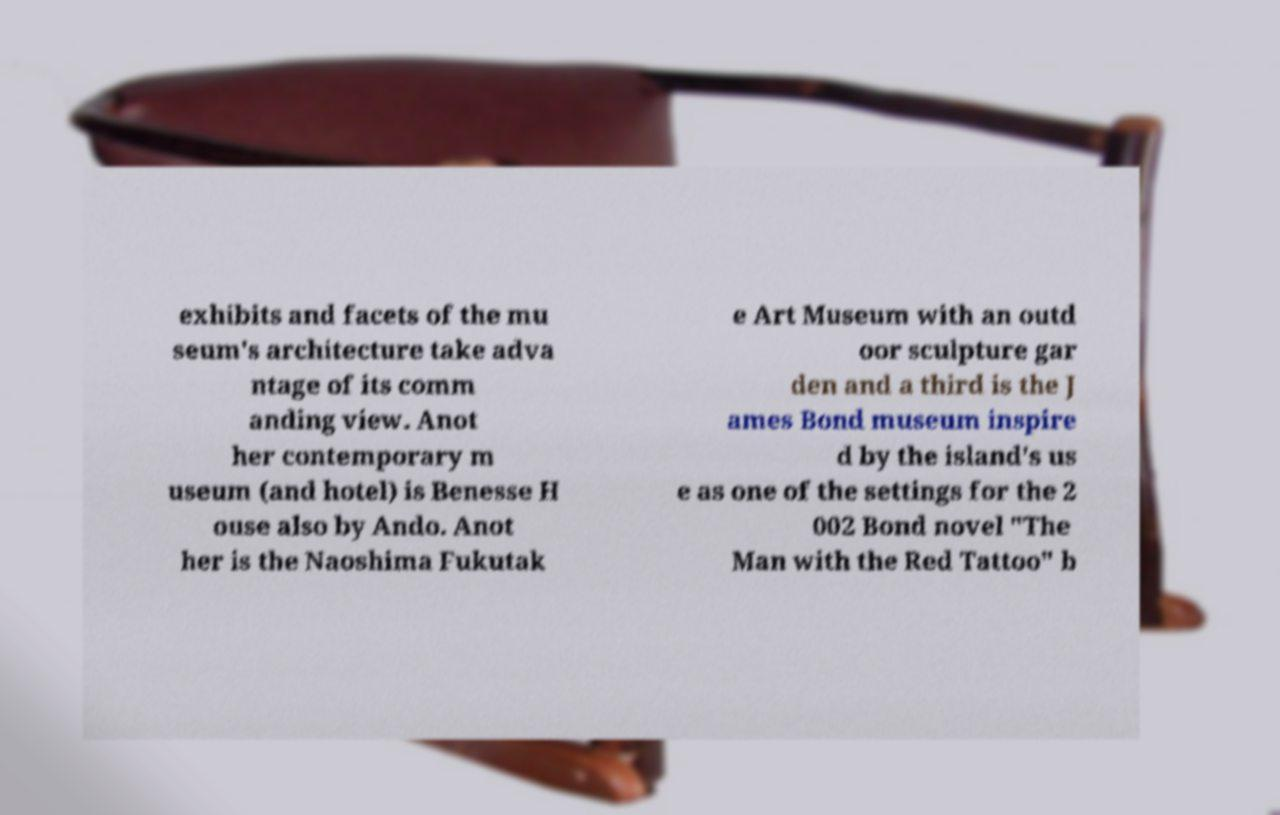Can you read and provide the text displayed in the image?This photo seems to have some interesting text. Can you extract and type it out for me? exhibits and facets of the mu seum's architecture take adva ntage of its comm anding view. Anot her contemporary m useum (and hotel) is Benesse H ouse also by Ando. Anot her is the Naoshima Fukutak e Art Museum with an outd oor sculpture gar den and a third is the J ames Bond museum inspire d by the island's us e as one of the settings for the 2 002 Bond novel "The Man with the Red Tattoo" b 